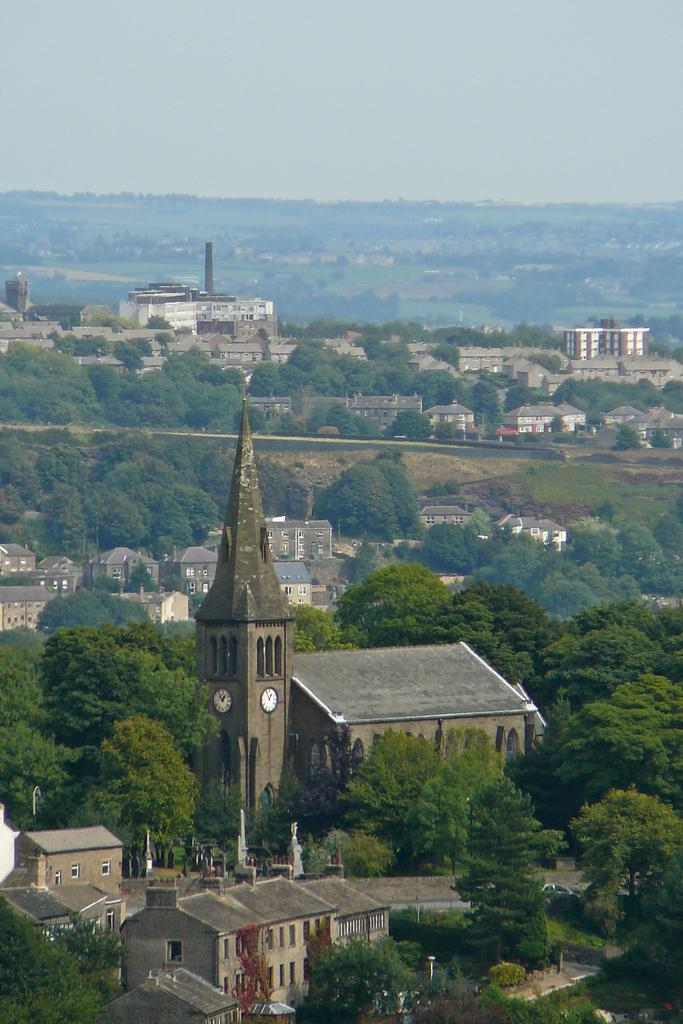What is present on two walls of the tower in the image? There is a clock on two walls of the tower. What can be seen on the ground in the image? There are trees, buildings, and plants on the ground. What is visible in the background of the image? The sky is visible in the background. What type of wire is being used by the nation in the image? There is no mention of a nation or wire in the image; it features a tower with a clock and various elements on the ground. 